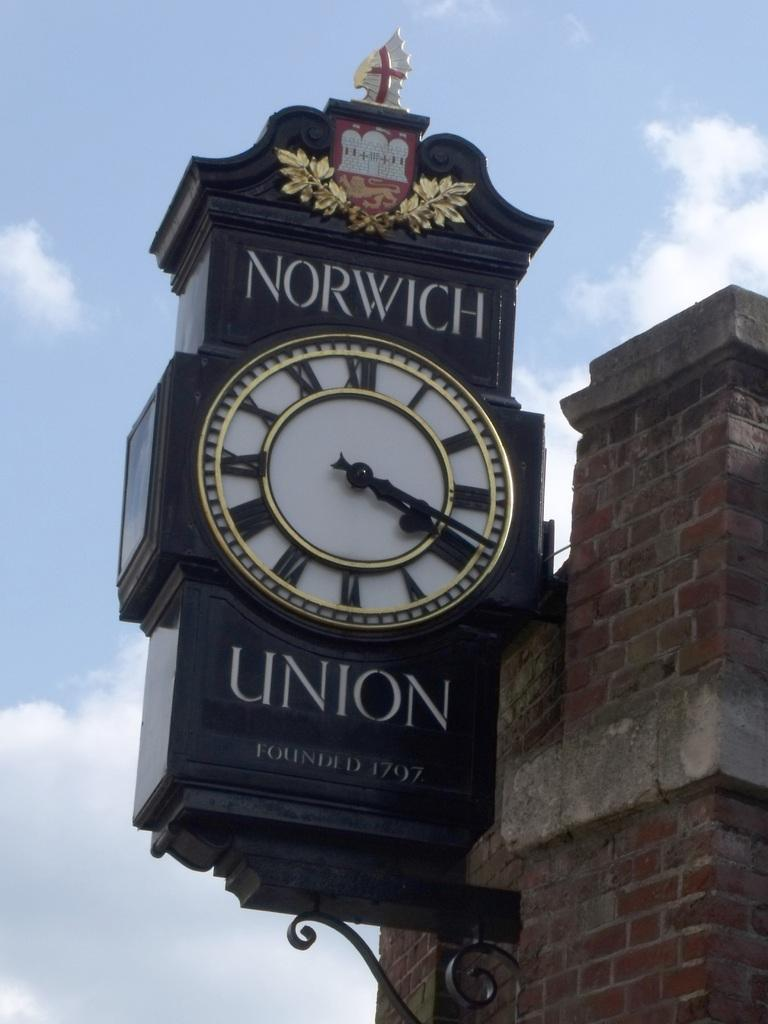<image>
Write a terse but informative summary of the picture. An outdoor post for Norwich Union with a large clock. 